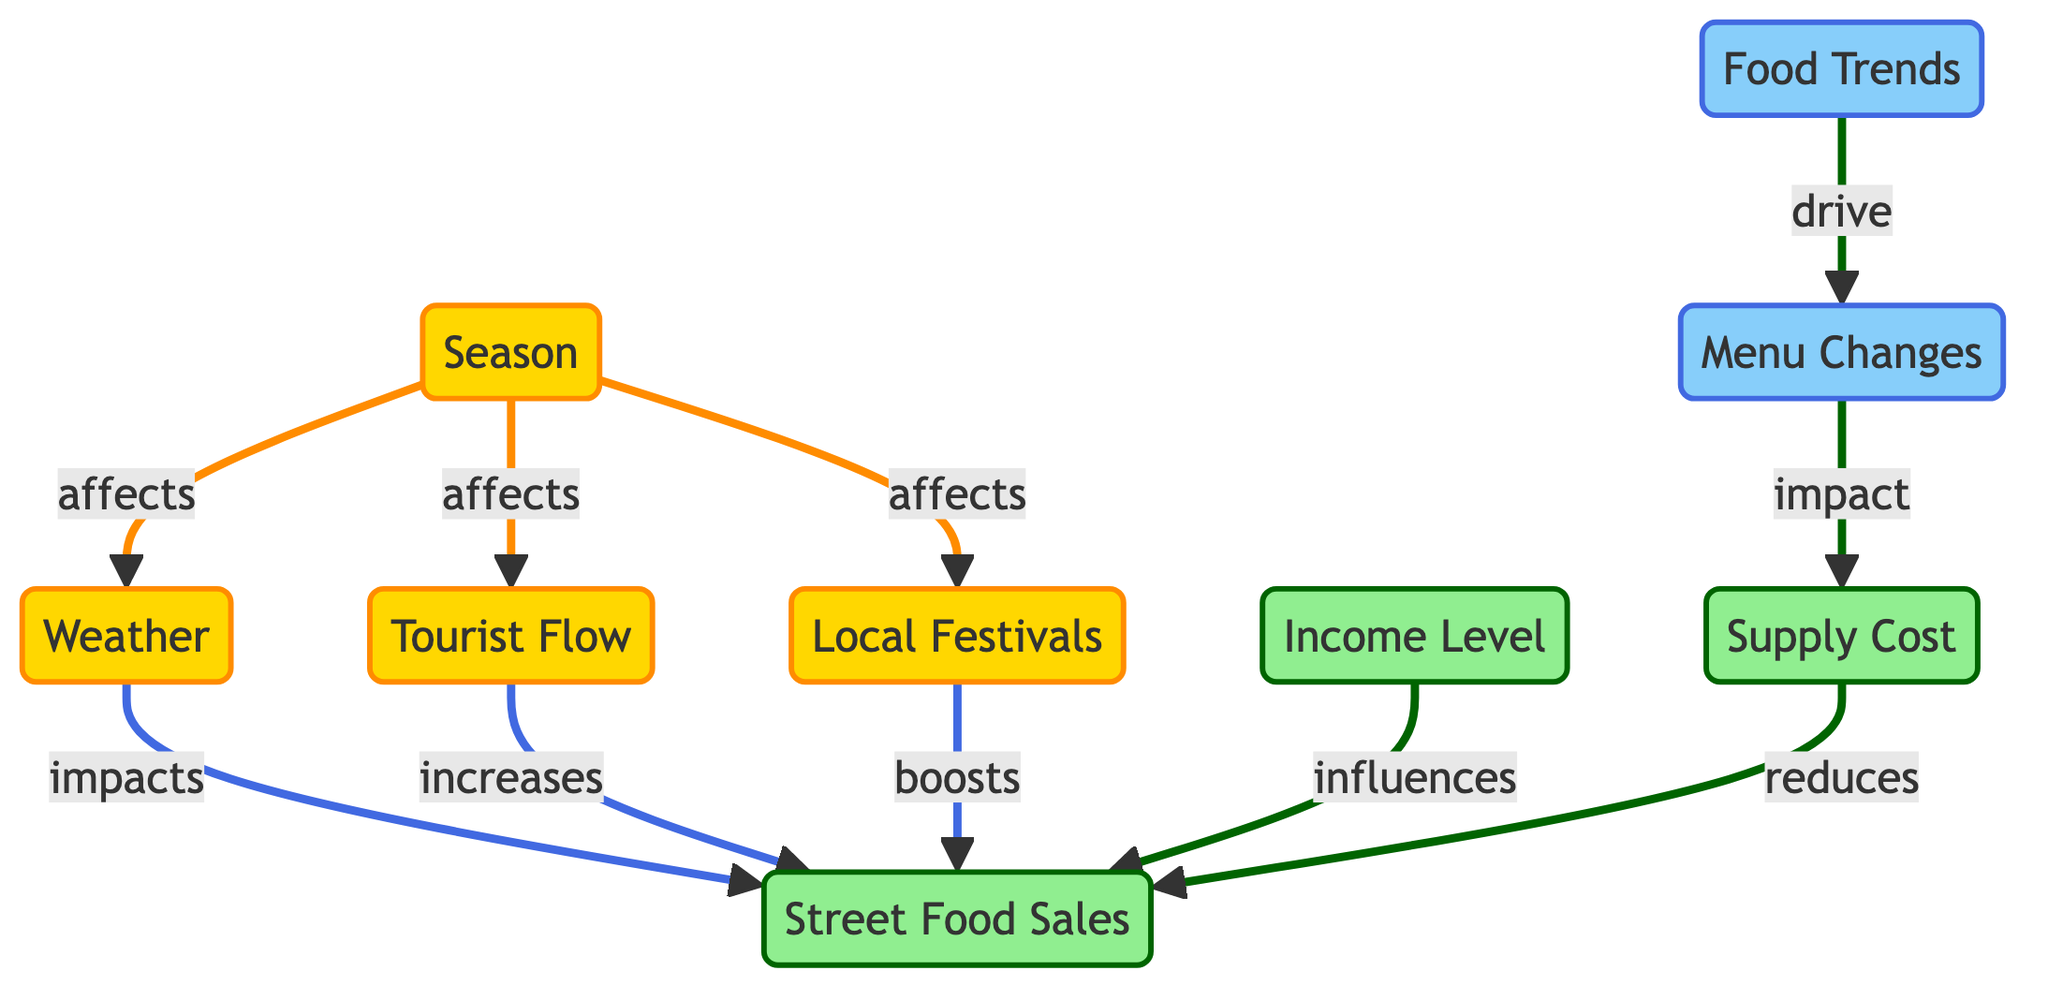What is the total number of nodes in the diagram? The diagram lists nine unique elements, which are represented as nodes. These include Season, Weather, Tourist Flow, Local Festivals, Income Level, Food Trends, Menu Changes, Supply Cost, and Street Food Sales. Counting all nodes gives us a total of nine.
Answer: 9 Which node affects Street Food Sales the most? Three nodes influence Street Food Sales directly: Weather impacts, Tourist Flow increases, and Local Festivals boost. Among them, Local Festivals is a strong determinant by using the word "boosts."
Answer: Local Festivals What relationship exists between Food Trends and Menu Changes? The diagram indicates that Food Trends "drive" Menu Changes, establishing a directional relationship from Food Trends to Menu Changes. The term "drive" signifies a direct influence.
Answer: drive How many edges are directed towards Street Food Sales? The edges directed towards Street Food Sales can be counted from the diagram. There are four edges leading to it: from Weather (impacts), Tourist Flow (increases), Local Festivals (boosts), and Income Level (influences).
Answer: 4 What effect does Season have on Local Festivals? The diagram shows that Season "affects" Local Festivals, indicating a directional relationship from Season to Local Festivals. This depicts how the change in season can influence local festival occurrences.
Answer: affects Which node influences Street Food Sales in terms of cost? The node Supply Cost relates to Street Food Sales by reducing it. The diagram clearly indicates that Supply Cost has a downward impact on Street Food Sales.
Answer: reduces Which factor is related to Menu Changes? The diagram identifies Food Trends as a factor related to Menu Changes, stating that Food Trends drive Menu Changes. This indicates that fluctuations in food trends impact the menu items offered.
Answer: Food Trends How does weather affect Street Food Sales? Weather impacts Street Food Sales, suggesting that changes in weather conditions can influence the sales figures for street food, as indicated by the diagram.
Answer: impacts What is the effect of tourist flow on Street Food Sales? According to the diagram, Tourist Flow increases Street Food Sales, highlighting the positive relationship between the number of tourists and the sales of street food.
Answer: increases 